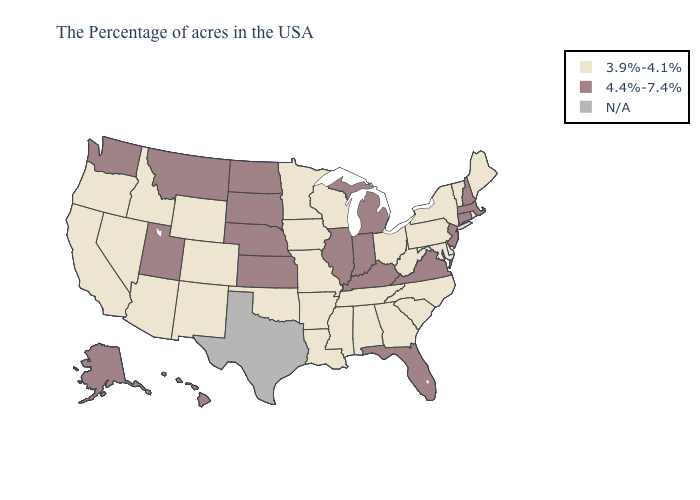Name the states that have a value in the range 4.4%-7.4%?
Concise answer only. Massachusetts, New Hampshire, Connecticut, New Jersey, Virginia, Florida, Michigan, Kentucky, Indiana, Illinois, Kansas, Nebraska, South Dakota, North Dakota, Utah, Montana, Washington, Alaska, Hawaii. Does California have the lowest value in the West?
Short answer required. Yes. What is the value of Louisiana?
Write a very short answer. 3.9%-4.1%. Is the legend a continuous bar?
Answer briefly. No. Name the states that have a value in the range N/A?
Write a very short answer. Texas. What is the lowest value in states that border Tennessee?
Answer briefly. 3.9%-4.1%. Name the states that have a value in the range 3.9%-4.1%?
Short answer required. Maine, Rhode Island, Vermont, New York, Delaware, Maryland, Pennsylvania, North Carolina, South Carolina, West Virginia, Ohio, Georgia, Alabama, Tennessee, Wisconsin, Mississippi, Louisiana, Missouri, Arkansas, Minnesota, Iowa, Oklahoma, Wyoming, Colorado, New Mexico, Arizona, Idaho, Nevada, California, Oregon. What is the lowest value in states that border Indiana?
Quick response, please. 3.9%-4.1%. What is the value of Michigan?
Give a very brief answer. 4.4%-7.4%. Which states have the lowest value in the USA?
Concise answer only. Maine, Rhode Island, Vermont, New York, Delaware, Maryland, Pennsylvania, North Carolina, South Carolina, West Virginia, Ohio, Georgia, Alabama, Tennessee, Wisconsin, Mississippi, Louisiana, Missouri, Arkansas, Minnesota, Iowa, Oklahoma, Wyoming, Colorado, New Mexico, Arizona, Idaho, Nevada, California, Oregon. Name the states that have a value in the range 3.9%-4.1%?
Concise answer only. Maine, Rhode Island, Vermont, New York, Delaware, Maryland, Pennsylvania, North Carolina, South Carolina, West Virginia, Ohio, Georgia, Alabama, Tennessee, Wisconsin, Mississippi, Louisiana, Missouri, Arkansas, Minnesota, Iowa, Oklahoma, Wyoming, Colorado, New Mexico, Arizona, Idaho, Nevada, California, Oregon. Which states have the highest value in the USA?
Write a very short answer. Massachusetts, New Hampshire, Connecticut, New Jersey, Virginia, Florida, Michigan, Kentucky, Indiana, Illinois, Kansas, Nebraska, South Dakota, North Dakota, Utah, Montana, Washington, Alaska, Hawaii. Does New Mexico have the highest value in the USA?
Short answer required. No. What is the value of Arkansas?
Be succinct. 3.9%-4.1%. Name the states that have a value in the range N/A?
Write a very short answer. Texas. 